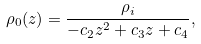Convert formula to latex. <formula><loc_0><loc_0><loc_500><loc_500>\rho _ { 0 } ( z ) = \frac { \rho _ { i } } { { - c } _ { 2 } z ^ { 2 } + c _ { 3 } z + c _ { 4 } } ,</formula> 